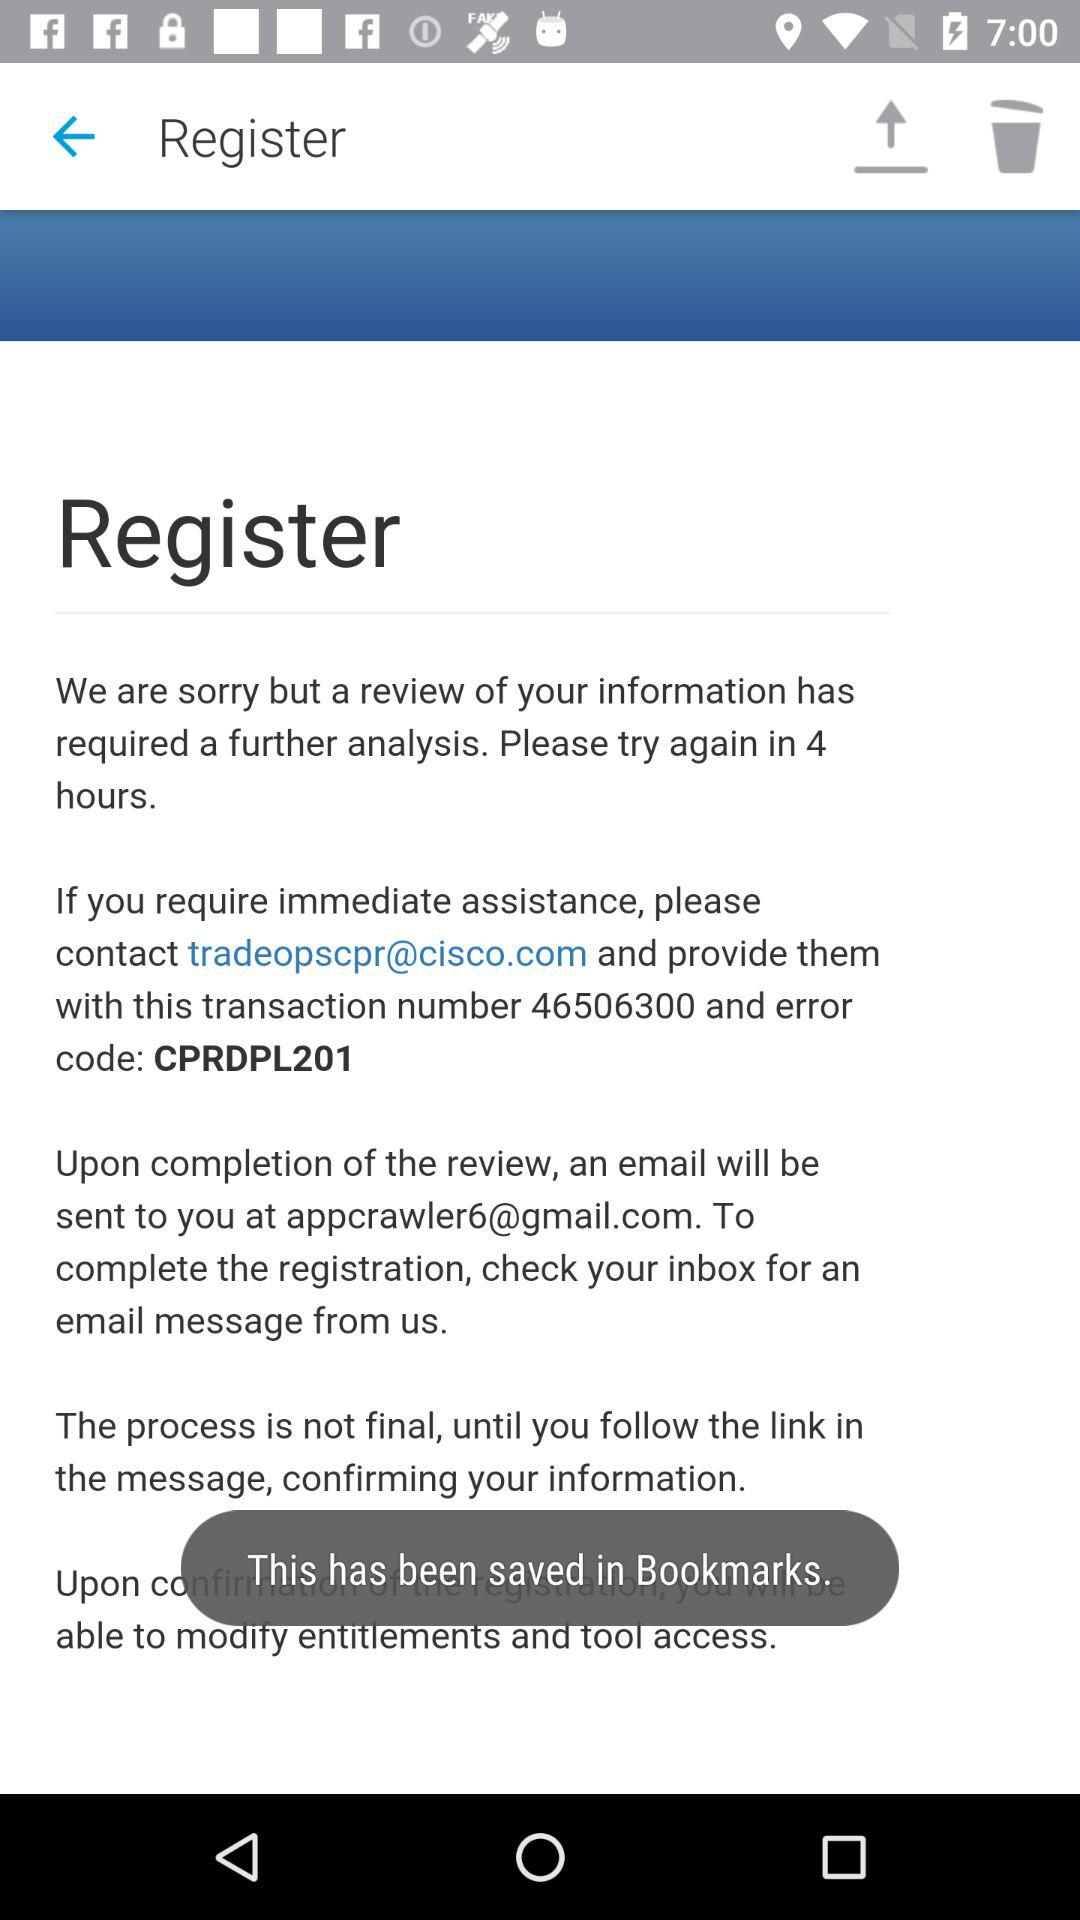How many hours do I have to wait to try again?
Answer the question using a single word or phrase. 4 